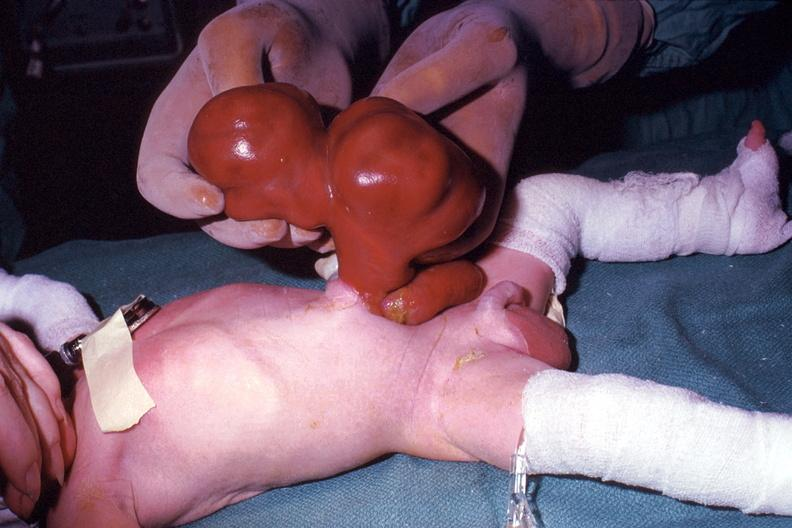what does this image show?
Answer the question using a single word or phrase. A photo taken during life large lesion 